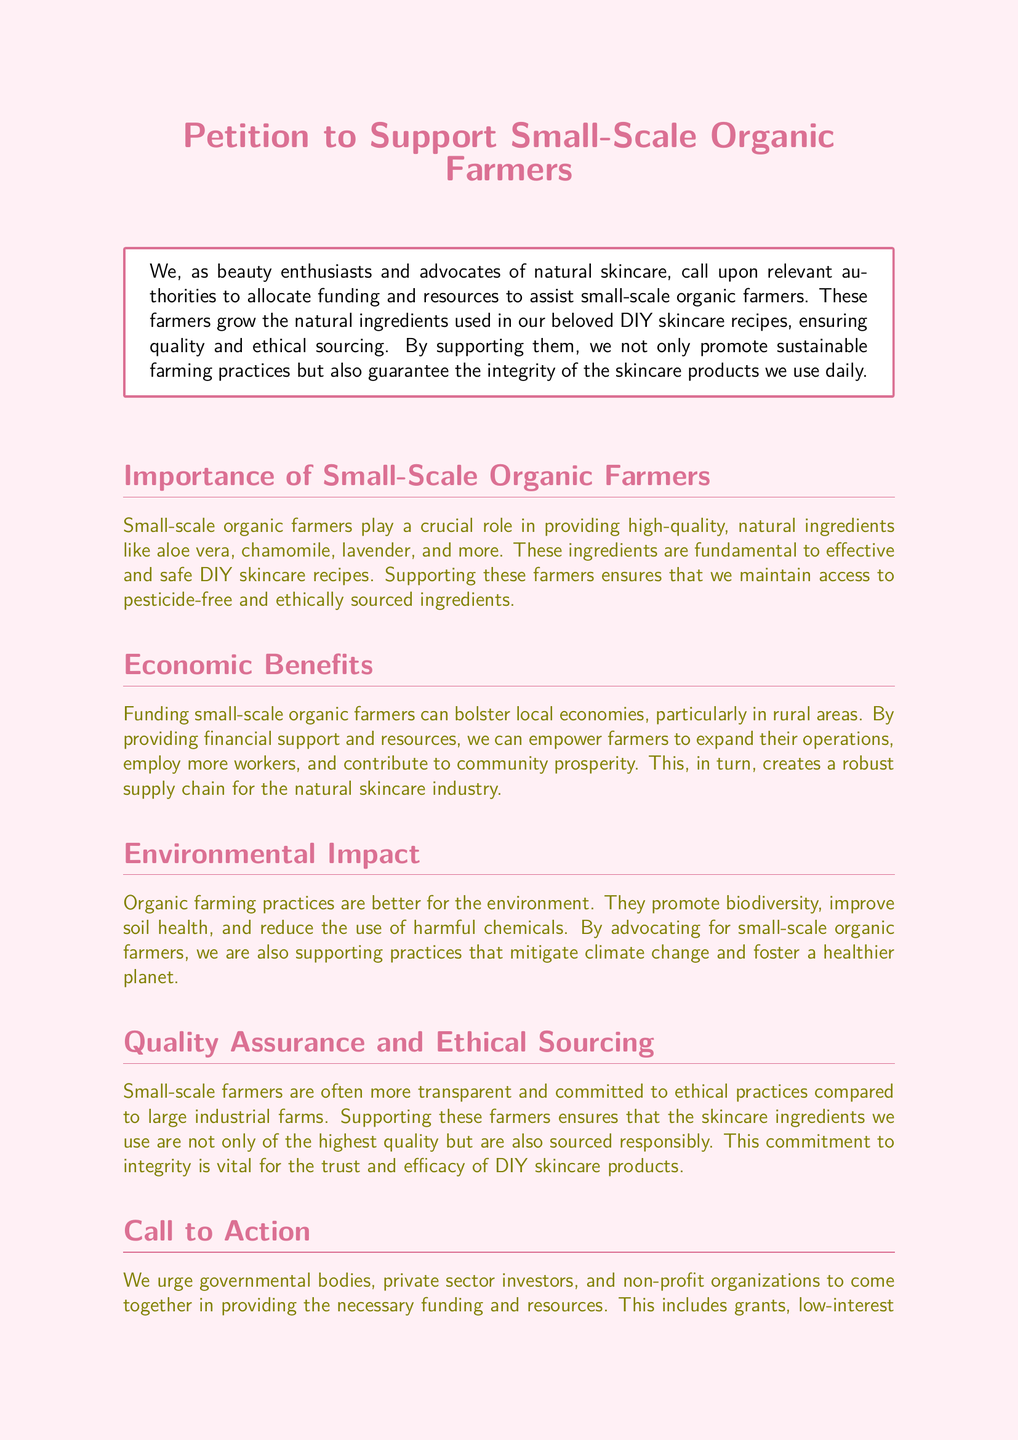What is the title of the petition? The title presented at the beginning of the document specifies the purpose of the petition, which is to support small-scale organic farmers.
Answer: Petition to Support Small-Scale Organic Farmers What ingredients are mentioned as being provided by small-scale organic farmers? The document lists specific natural ingredients essential for DIY skincare, highlighting their importance.
Answer: Aloe vera, chamomile, lavender What type of farming practices are better for the environment according to the document? The document emphasizes certain farming practices that are more beneficial for ecological health.
Answer: Organic farming practices What are the economic benefits of supporting small-scale organic farmers mentioned in the petition? The document states how supporting these farmers can affect local economies and workforce.
Answer: Empower farmers to expand operations How can governmental bodies assist small-scale organic farmers as mentioned in the call to action? The petition outlines specific types of support that governmental bodies can provide to help these farmers.
Answer: Grants, low-interest loans Why is quality assurance important according to the document? The document explains the significance of high-quality sourcing in the context of DIY skincare products.
Answer: Ensures highest quality and responsible sourcing What is a potential outcome of providing resources to small-scale organic farmers? The petition highlights the positive effects of financial and technical assistance on farming operations.
Answer: Contribute to community prosperity What does signing the petition signify for the movement? The document describes the implications of signing the petition regarding the values it supports.
Answer: Supporting sustainability and ethical sourcing 